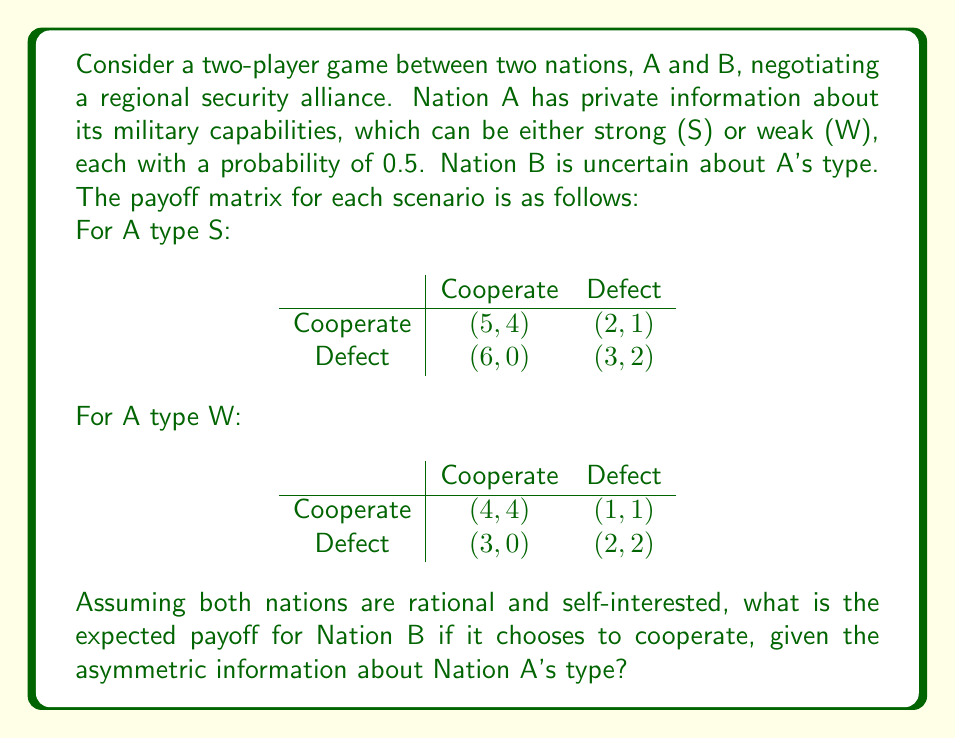Give your solution to this math problem. To solve this problem, we need to consider the strategy of Nation A for both its possible types (S and W) and calculate the expected payoff for Nation B when it chooses to cooperate.

Step 1: Analyze Nation A's dominant strategy for each type.

For type S:
- If B cooperates, A gets 5 for cooperating and 6 for defecting.
- If B defects, A gets 2 for cooperating and 3 for defecting.
Defecting is always better for A when it's type S.

For type W:
- If B cooperates, A gets 4 for cooperating and 3 for defecting.
- If B defects, A gets 1 for cooperating and 2 for defecting.
Cooperating is better when B cooperates, but defecting is better when B defects.

Step 2: Determine Nation A's strategy.
Given that Nation A knows its type but Nation B doesn't, A will always defect when it's type S. When it's type W, A might cooperate if it believes B will cooperate.

Step 3: Calculate expected payoff for Nation B when it cooperates.
The expected payoff is the weighted average of the payoffs from both scenarios:

$$E(\text{Payoff}_B) = P(A \text{ is S}) \cdot \text{Payoff}(B \text{ coop, A defect}) + P(A \text{ is W}) \cdot \text{Payoff}(B \text{ coop, A coop})$$

$$E(\text{Payoff}_B) = 0.5 \cdot 0 + 0.5 \cdot 4 = 2$$

This calculation assumes that when A is type W, it will cooperate if B cooperates. However, this may not always be the case, as A (type W) might still defect to get a payoff of 3 instead of 4.

Step 4: Consider the uncertainty.
Given the skepticism about regional alliances, Nation A (even when type W) might be inclined to defect regardless of B's action. In this case, the expected payoff for B would be:

$$E(\text{Payoff}_B) = 0.5 \cdot 0 + 0.5 \cdot 1 = 0.5$$

The actual expected payoff likely lies between these two values, depending on the probability of Nation A (type W) cooperating.
Answer: The expected payoff for Nation B when choosing to cooperate, given the asymmetric information about Nation A's type, is between 0.5 and 2, with the exact value depending on the probability of Nation A (type W) cooperating. If we assume Nation A always acts in its immediate self-interest, the expected payoff for Nation B is 0.5. 